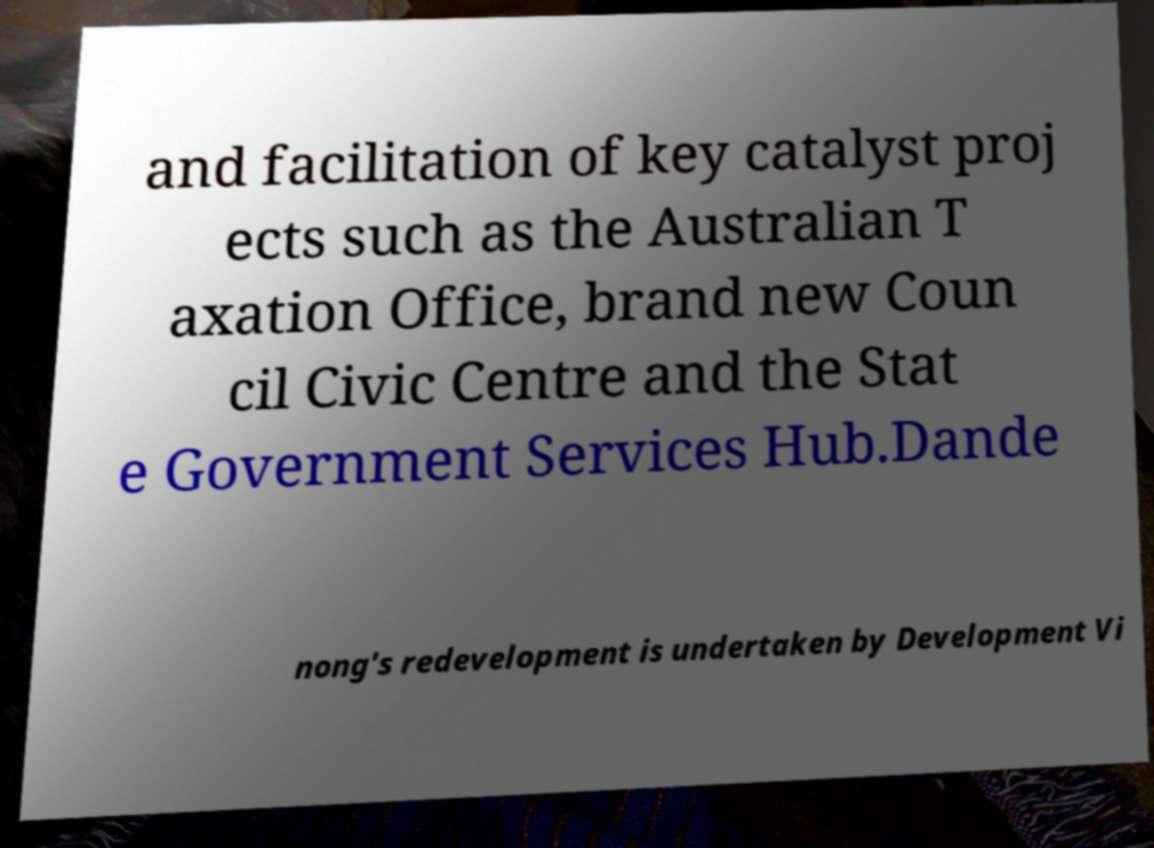Can you read and provide the text displayed in the image?This photo seems to have some interesting text. Can you extract and type it out for me? and facilitation of key catalyst proj ects such as the Australian T axation Office, brand new Coun cil Civic Centre and the Stat e Government Services Hub.Dande nong's redevelopment is undertaken by Development Vi 